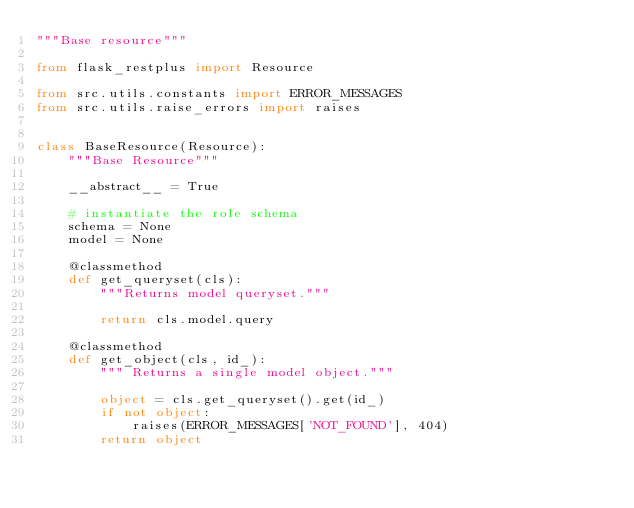<code> <loc_0><loc_0><loc_500><loc_500><_Python_>"""Base resource"""

from flask_restplus import Resource

from src.utils.constants import ERROR_MESSAGES
from src.utils.raise_errors import raises


class BaseResource(Resource):
    """Base Resource"""

    __abstract__ = True

    # instantiate the role schema
    schema = None
    model = None

    @classmethod
    def get_queryset(cls):
        """Returns model queryset."""

        return cls.model.query

    @classmethod
    def get_object(cls, id_):
        """ Returns a single model object."""

        object = cls.get_queryset().get(id_)
        if not object:
            raises(ERROR_MESSAGES['NOT_FOUND'], 404)
        return object
</code> 